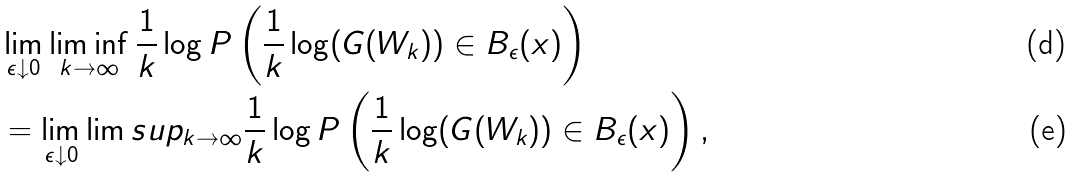Convert formula to latex. <formula><loc_0><loc_0><loc_500><loc_500>& \lim _ { \epsilon \downarrow 0 } \liminf _ { k \rightarrow \infty } \frac { 1 } { k } \log P \left ( \frac { 1 } { k } \log ( G ( W _ { k } ) ) \in B _ { \epsilon } ( x ) \right ) \\ & = \lim _ { \epsilon \downarrow 0 } \lim s u p _ { k \rightarrow \infty } \frac { 1 } { k } \log P \left ( \frac { 1 } { k } \log ( G ( W _ { k } ) ) \in B _ { \epsilon } ( x ) \right ) ,</formula> 